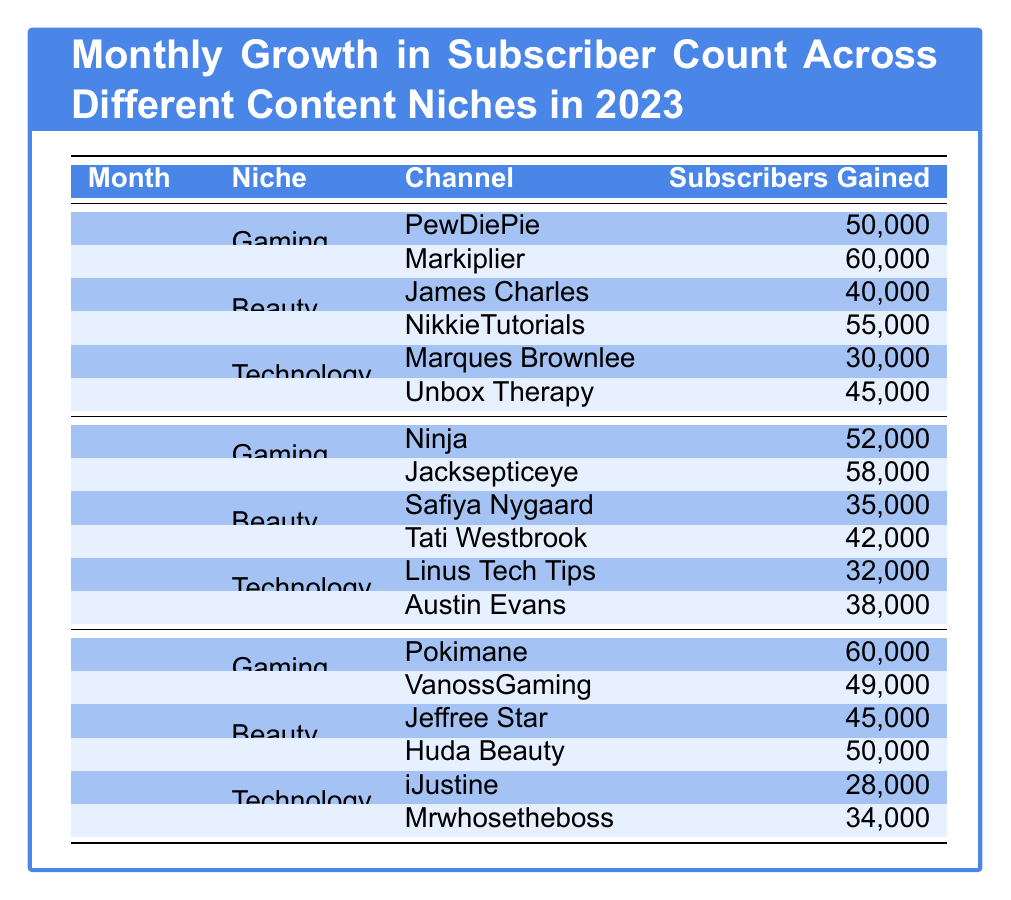What channel gained the most subscribers in January? In the Gaming niche for January, Markiplier gained 60,000 subscribers, which is the highest number among all channels listed in that month.
Answer: Markiplier What is the total subscribers gained by channels in the Beauty niche for March? For March, the channels in Beauty gained 45,000 (Jeffree Star) + 50,000 (Huda Beauty) = 95,000 subscribers in total.
Answer: 95,000 Did Marques Brownlee gain more subscribers than Safiya Nygaard in February? Marques Brownlee gained 30,000 subscribers in January while Safiya Nygaard gained 35,000 in February. Therefore, Safiya Nygaard gained more than Marques Brownlee.
Answer: No Which niche had the highest overall subscriber gains in January? Adding the subscribers for each niche: Gaming (50,000 + 60,000 = 110,000), Beauty (40,000 + 55,000 = 95,000), Technology (30,000 + 45,000 = 75,000). Gaming had the highest total with 110,000 subscribers.
Answer: Gaming What was the average subscribers gained by channels in the Technology niche across all three months? In January, Technology gained 30,000 + 45,000 = 75,000; in February, 32,000 + 38,000 = 70,000; in March, 28,000 + 34,000 = 62,000. The total for Technology is 75,000 + 70,000 + 62,000 = 207,000. There are 3 months, so the average is 207,000 / 3 = 69,000.
Answer: 69,000 Which channel gained more subscribers in February, Ninja or Jacksepticeye? Ninja gained 52,000 subscribers, while Jacksepticeye gained 58,000 subscribers in February. Thus, Jacksepticeye gained more subscribers than Ninja.
Answer: Jacksepticeye How many subscribers did channels in the Gaming niche gain in total for the first quarter? For Gaming in January, 110,000; February, 52,000 + 58,000 = 110,000; March, 60,000 + 49,000 = 109,000. The total for Gaming across all three months is 110,000 + 110,000 + 109,000 = 329,000.
Answer: 329,000 